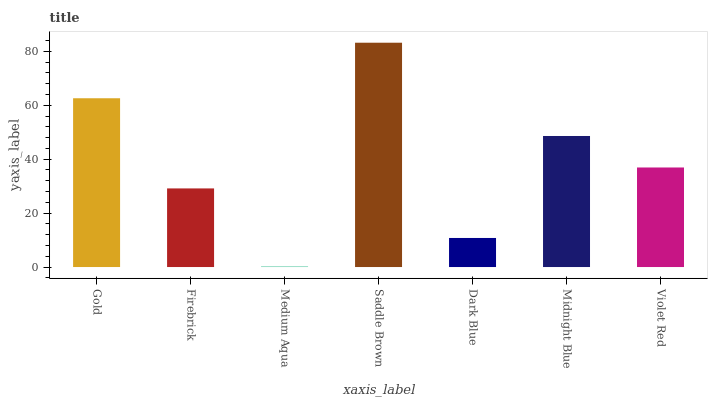Is Medium Aqua the minimum?
Answer yes or no. Yes. Is Saddle Brown the maximum?
Answer yes or no. Yes. Is Firebrick the minimum?
Answer yes or no. No. Is Firebrick the maximum?
Answer yes or no. No. Is Gold greater than Firebrick?
Answer yes or no. Yes. Is Firebrick less than Gold?
Answer yes or no. Yes. Is Firebrick greater than Gold?
Answer yes or no. No. Is Gold less than Firebrick?
Answer yes or no. No. Is Violet Red the high median?
Answer yes or no. Yes. Is Violet Red the low median?
Answer yes or no. Yes. Is Dark Blue the high median?
Answer yes or no. No. Is Saddle Brown the low median?
Answer yes or no. No. 